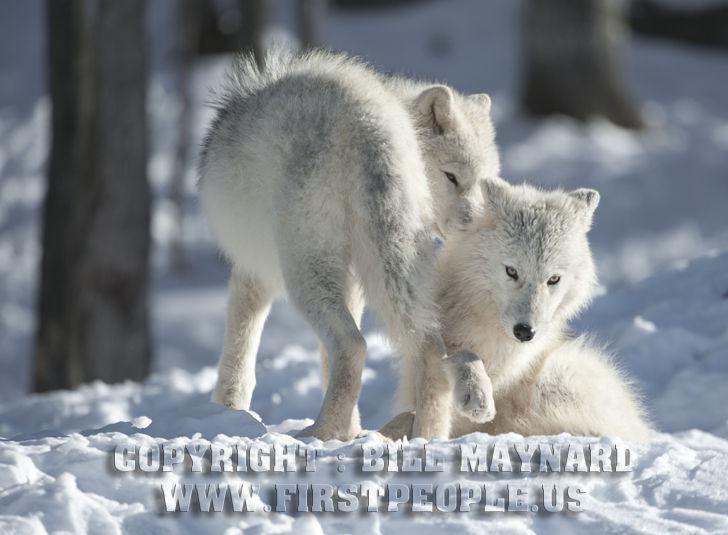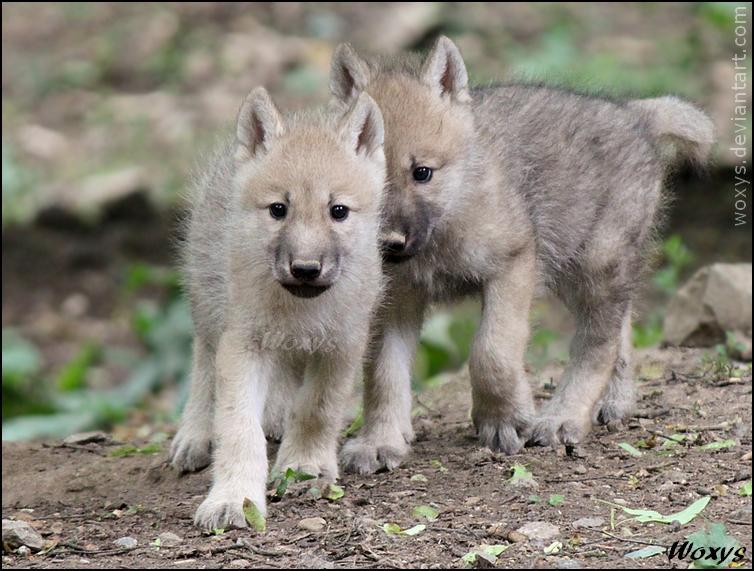The first image is the image on the left, the second image is the image on the right. Examine the images to the left and right. Is the description "Two young white wolves are standing on a boulder." accurate? Answer yes or no. No. The first image is the image on the left, the second image is the image on the right. For the images shown, is this caption "Each image contains two wolves, and one image shows the wolves standing on a boulder with tiers of boulders behind them." true? Answer yes or no. No. 